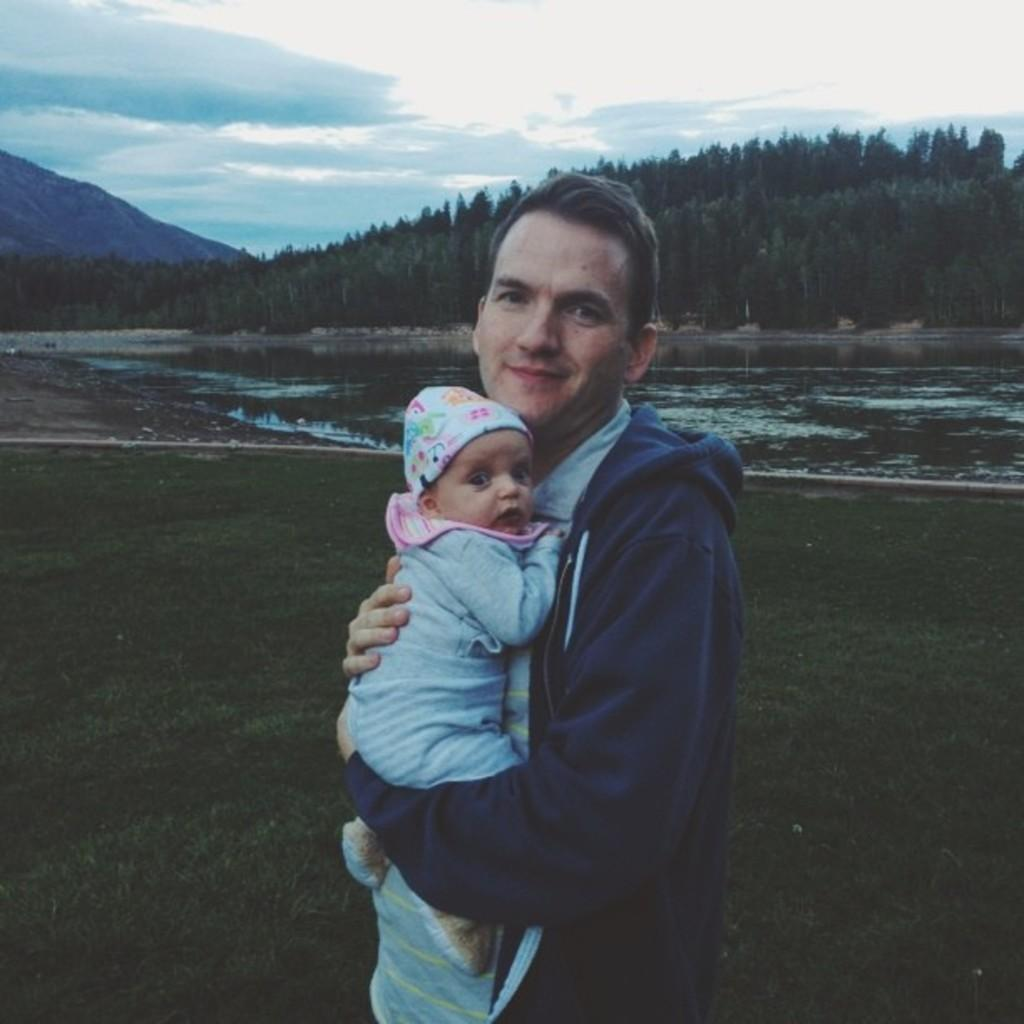Who is present in the image? There is a man in the image. What is the man wearing? The man is wearing a navy blue hoodie. What is the man doing in the image? The man is holding a baby. What can be seen in the background of the image? There is a lake, hills with trees, and the sky visible in the image. What is the condition of the sky in the image? Clouds are present in the sky. What type of air is being used to propel the boat on the lake in the image? There is no boat present on the lake in the image, so it is not possible to determine what type of air might be used to propel a boat. 